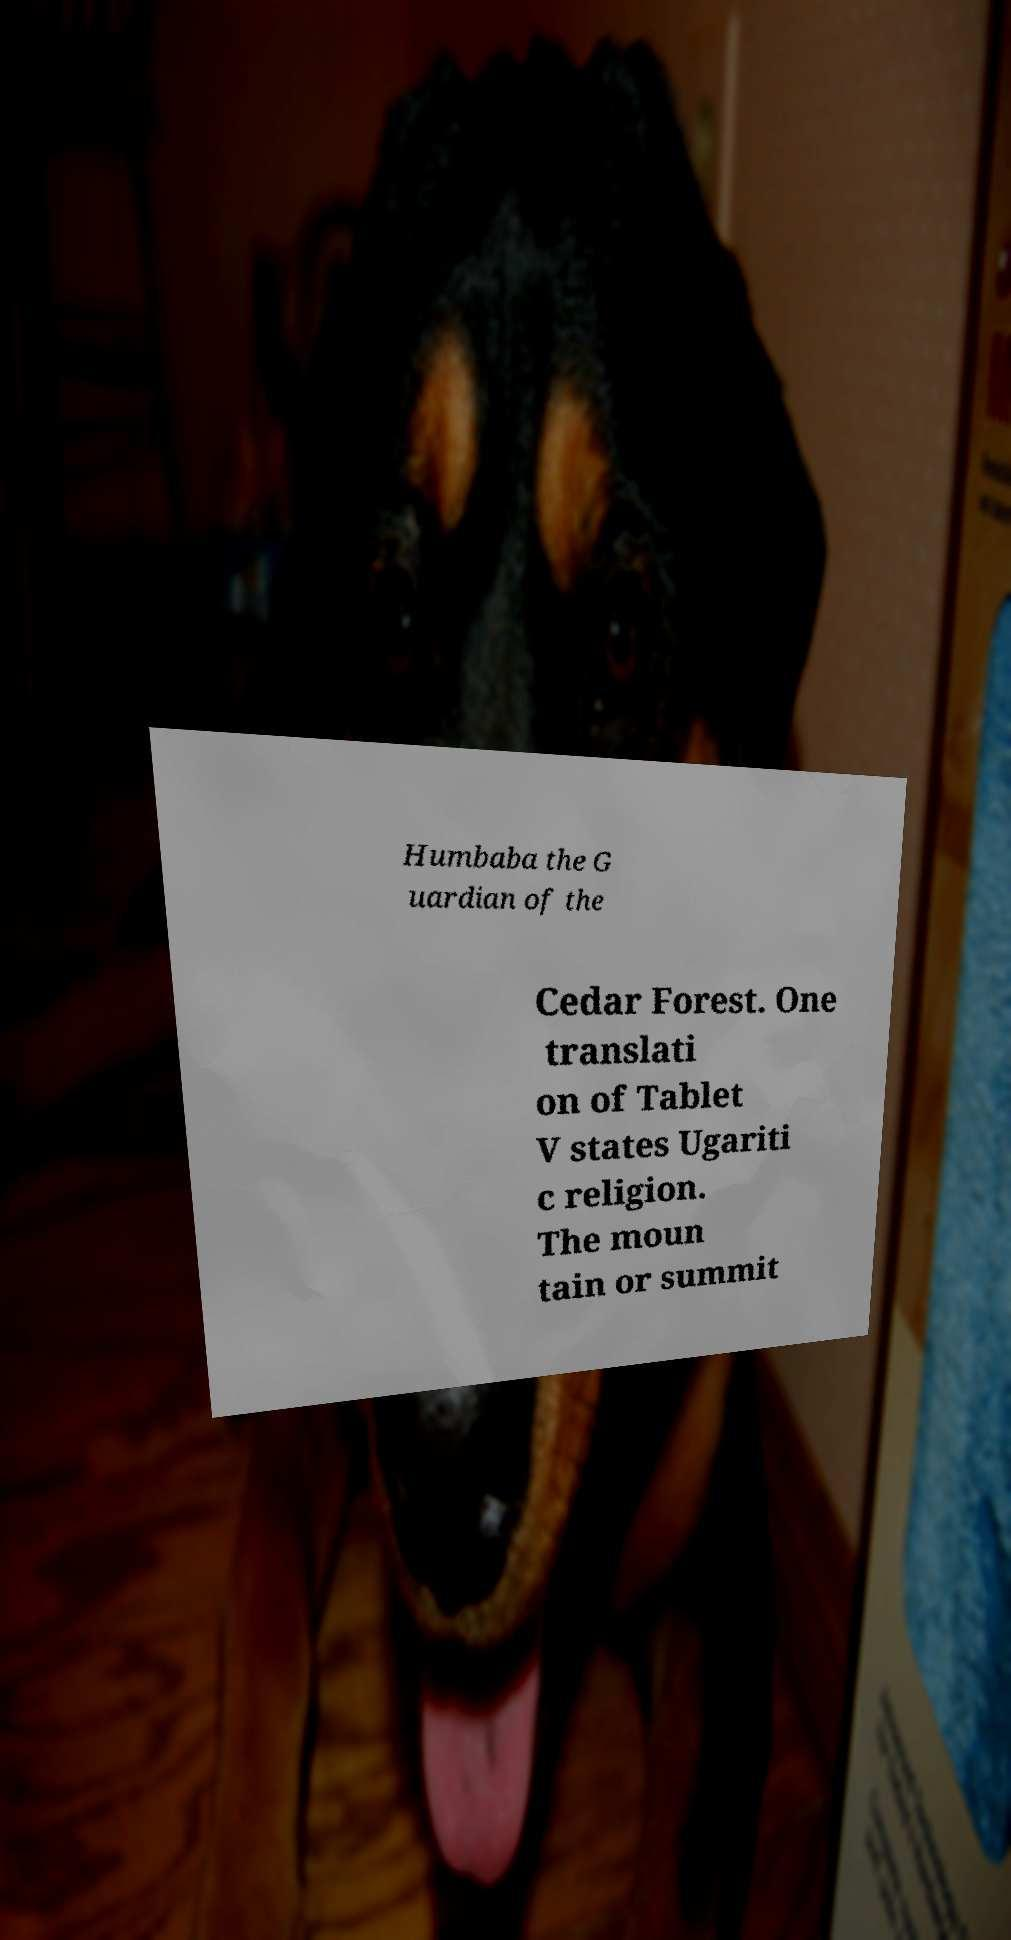Could you extract and type out the text from this image? Humbaba the G uardian of the Cedar Forest. One translati on of Tablet V states Ugariti c religion. The moun tain or summit 